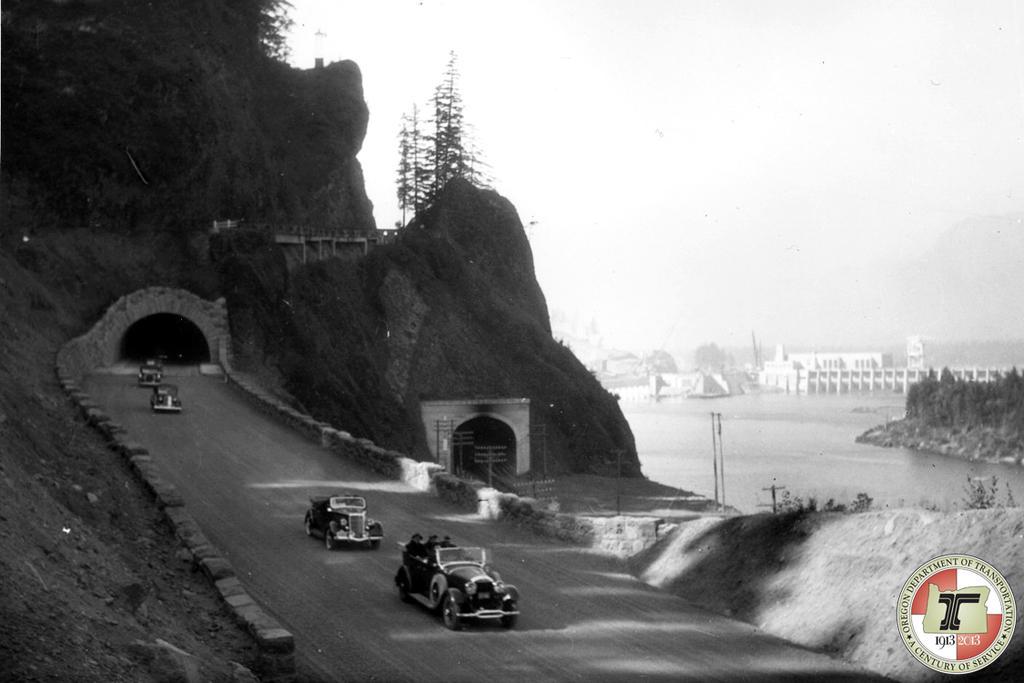Could you give a brief overview of what you see in this image? This is a black and white image. We can see the ground. There are a few vehicles. We can see some hills and underpasses. We can see some trees. We can see a few buildings, plants and poles. We can also see some water. We can also see a watermark on the bottom right corner. 